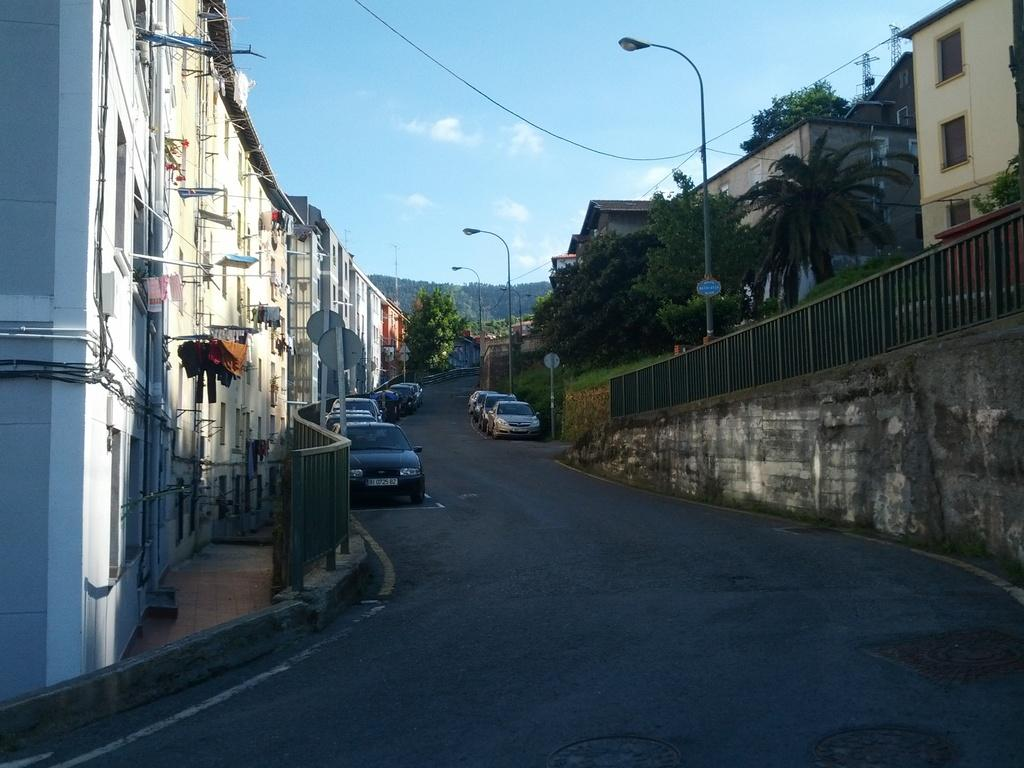What can be seen on the road in the image? There are vehicles on the road in the image. What type of lighting is present along the road? Street lights are present in the image. What type of barrier can be seen in the image? Fences are visible in the image. What type of structures are present in the image? There are buildings in the image. What part of the buildings can be seen in the image? Windows are present in the image. What type of infrastructure is visible on the walls in the image? Pipes on the walls are visible in the image. What type of clothing is present in the image? Clothes are present in the image. What type of vegetation is visible in the image? Trees are visible in the image. What type of vertical structures are present in the image? Poles are present in the image. What type of electrical infrastructure is visible in the image? Wires are visible in the image. What type of objects are present in the image? Objects are present in the image. What can be seen in the sky in the image? Clouds are visible in the sky in the image. Can you tell me how much pleasure the boat in the image is providing to the people? There is no boat present in the image, so it is not possible to determine the pleasure it might provide to people. What type of wealth is depicted in the image? The image does not depict any wealth or financial status; it contains vehicles, street lights, fences, buildings, windows, pipes, clothes, trees, poles, wires, objects, and clouds. 